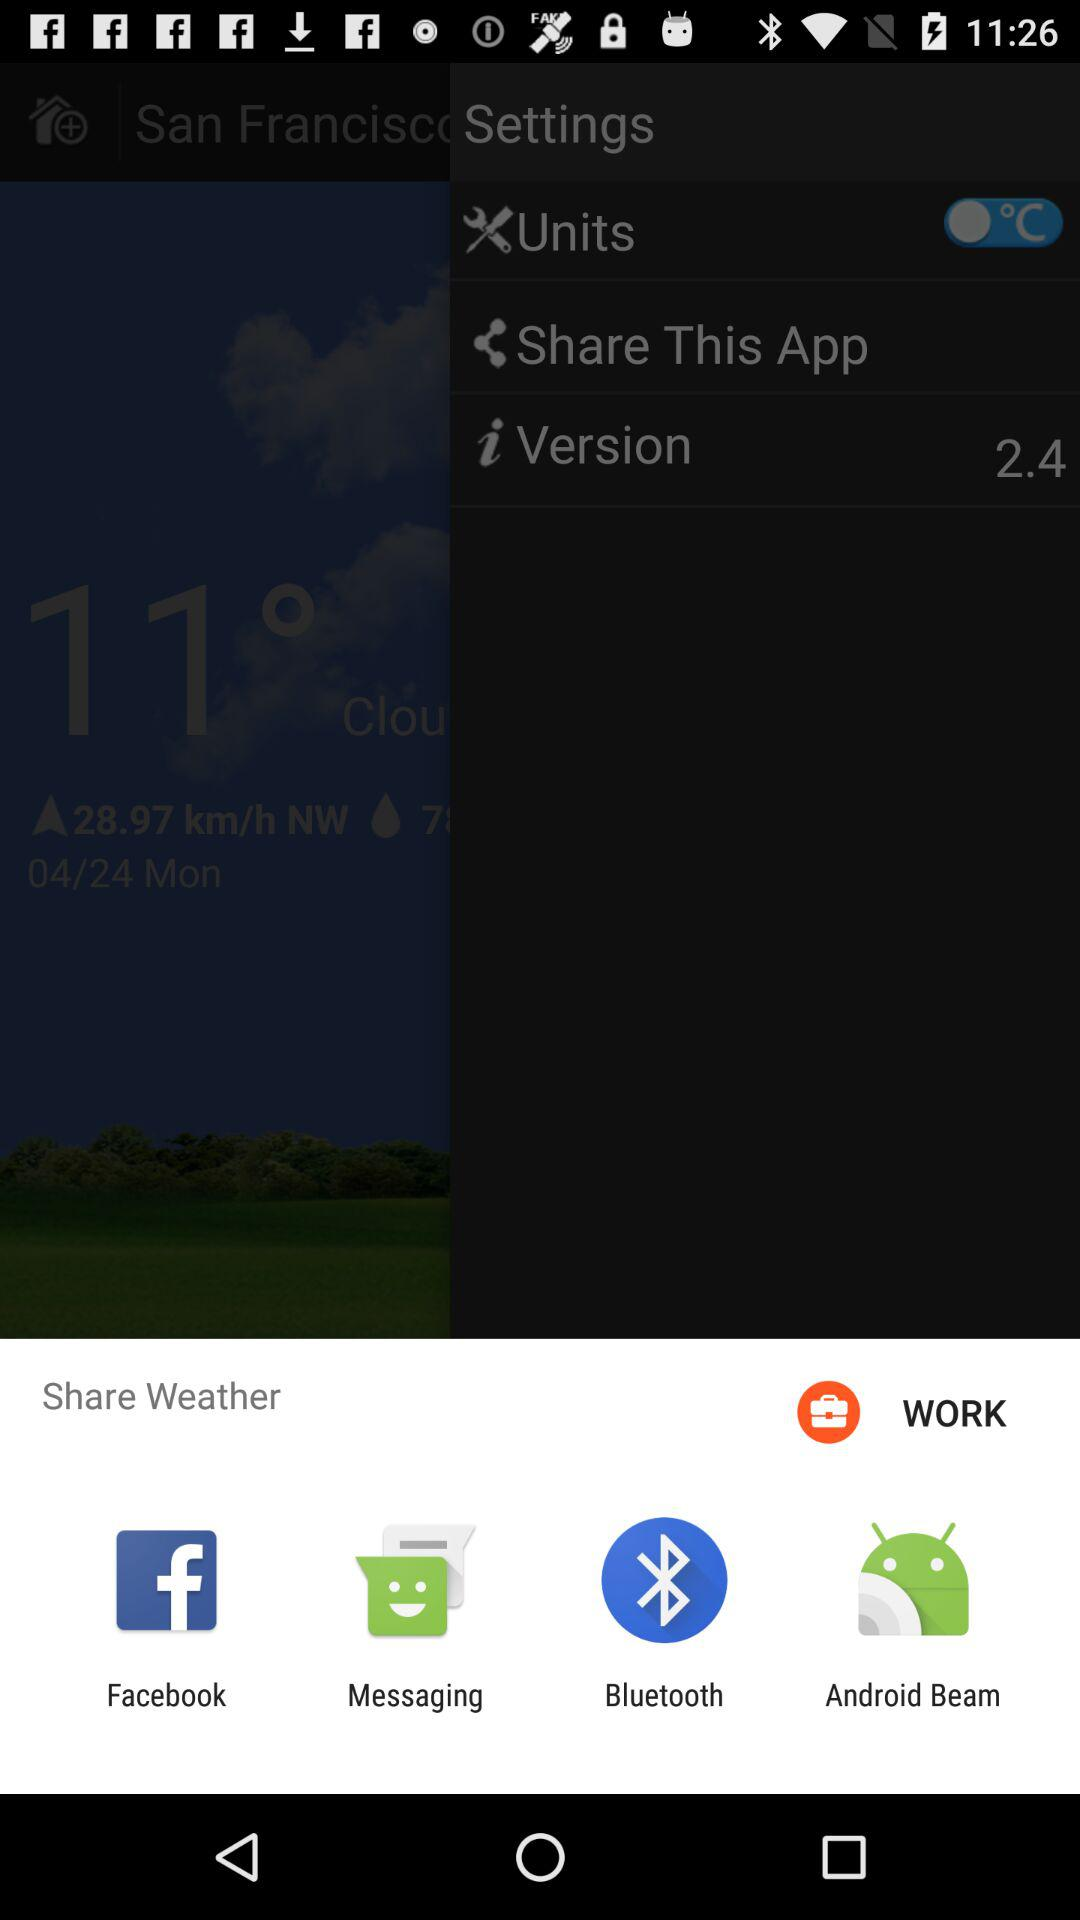What is the version of the app? The version is 2.4. 